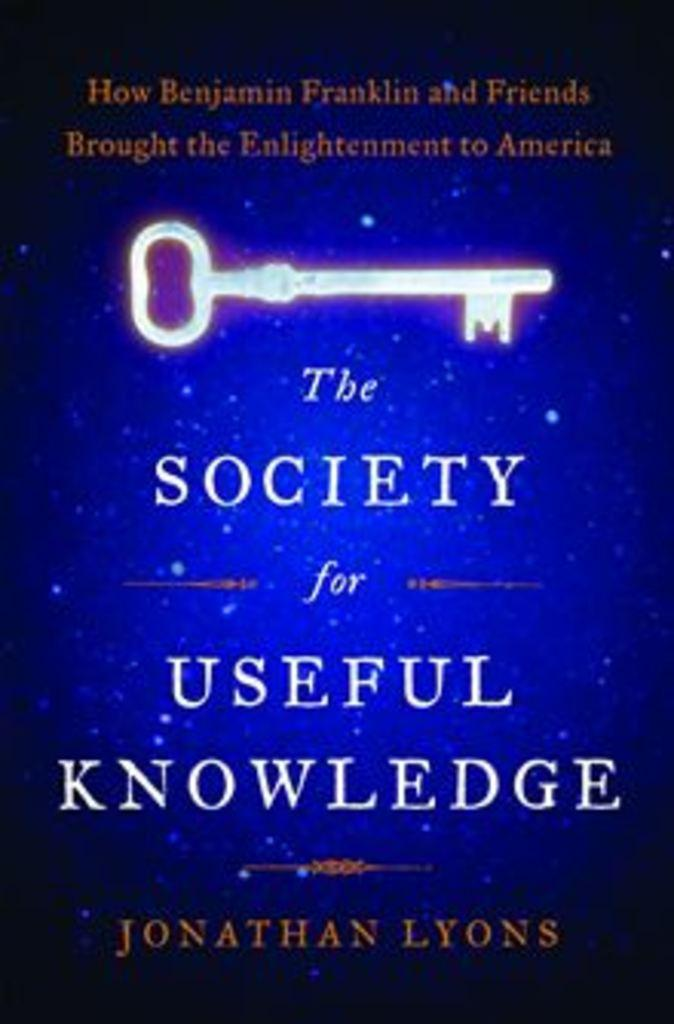Provide a one-sentence caption for the provided image. A book entitled The Society for Useful Knowledge features an image of a key on its cover. 